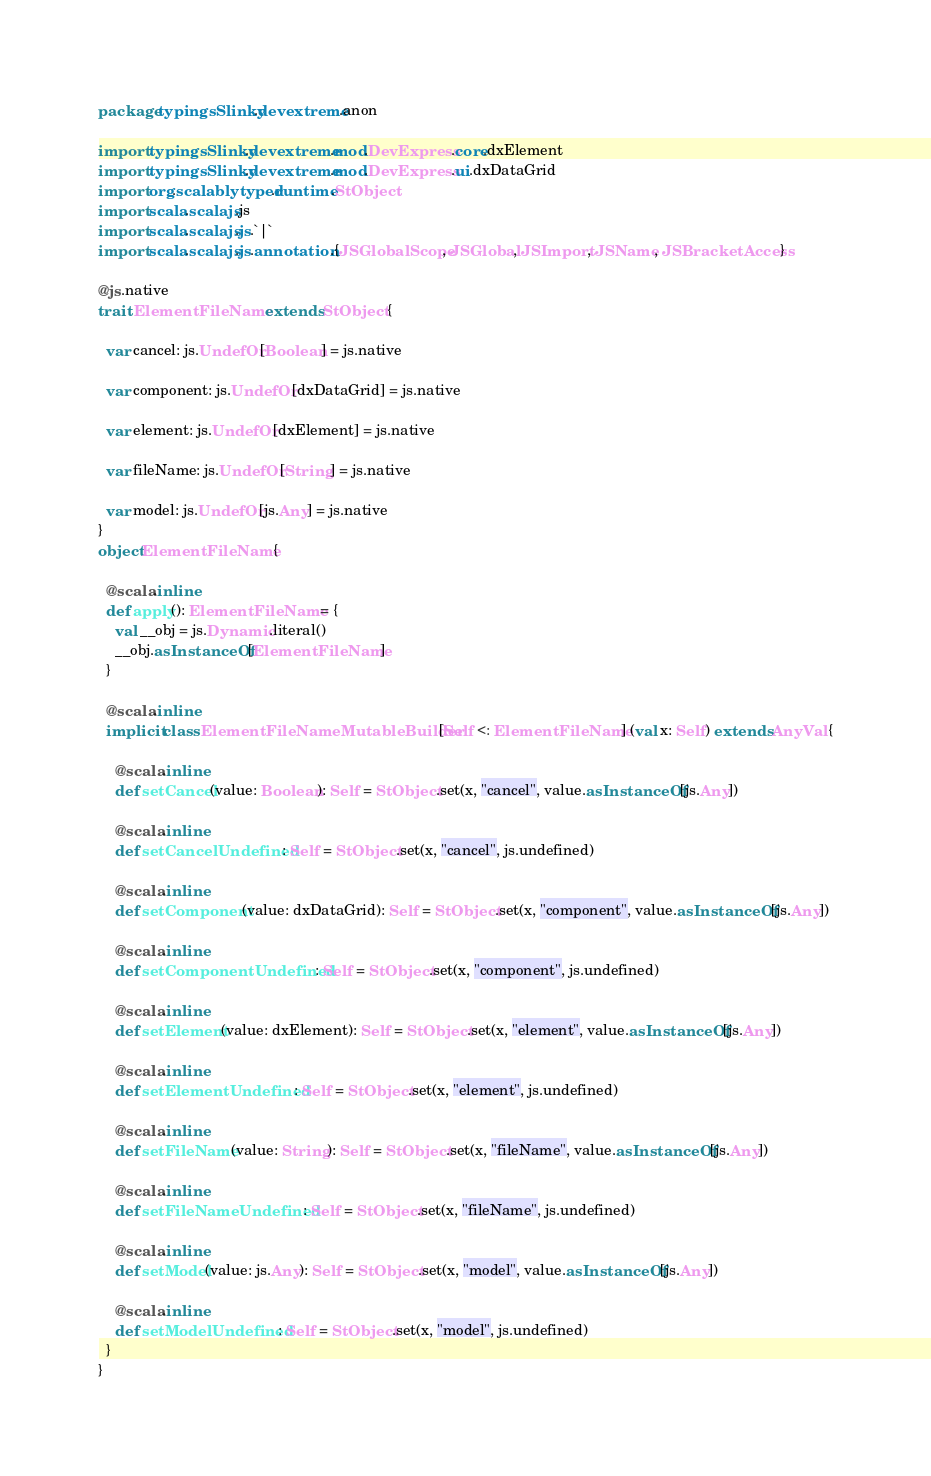Convert code to text. <code><loc_0><loc_0><loc_500><loc_500><_Scala_>package typingsSlinky.devextreme.anon

import typingsSlinky.devextreme.mod.DevExpress.core.dxElement
import typingsSlinky.devextreme.mod.DevExpress.ui.dxDataGrid
import org.scalablytyped.runtime.StObject
import scala.scalajs.js
import scala.scalajs.js.`|`
import scala.scalajs.js.annotation.{JSGlobalScope, JSGlobal, JSImport, JSName, JSBracketAccess}

@js.native
trait ElementFileName extends StObject {
  
  var cancel: js.UndefOr[Boolean] = js.native
  
  var component: js.UndefOr[dxDataGrid] = js.native
  
  var element: js.UndefOr[dxElement] = js.native
  
  var fileName: js.UndefOr[String] = js.native
  
  var model: js.UndefOr[js.Any] = js.native
}
object ElementFileName {
  
  @scala.inline
  def apply(): ElementFileName = {
    val __obj = js.Dynamic.literal()
    __obj.asInstanceOf[ElementFileName]
  }
  
  @scala.inline
  implicit class ElementFileNameMutableBuilder[Self <: ElementFileName] (val x: Self) extends AnyVal {
    
    @scala.inline
    def setCancel(value: Boolean): Self = StObject.set(x, "cancel", value.asInstanceOf[js.Any])
    
    @scala.inline
    def setCancelUndefined: Self = StObject.set(x, "cancel", js.undefined)
    
    @scala.inline
    def setComponent(value: dxDataGrid): Self = StObject.set(x, "component", value.asInstanceOf[js.Any])
    
    @scala.inline
    def setComponentUndefined: Self = StObject.set(x, "component", js.undefined)
    
    @scala.inline
    def setElement(value: dxElement): Self = StObject.set(x, "element", value.asInstanceOf[js.Any])
    
    @scala.inline
    def setElementUndefined: Self = StObject.set(x, "element", js.undefined)
    
    @scala.inline
    def setFileName(value: String): Self = StObject.set(x, "fileName", value.asInstanceOf[js.Any])
    
    @scala.inline
    def setFileNameUndefined: Self = StObject.set(x, "fileName", js.undefined)
    
    @scala.inline
    def setModel(value: js.Any): Self = StObject.set(x, "model", value.asInstanceOf[js.Any])
    
    @scala.inline
    def setModelUndefined: Self = StObject.set(x, "model", js.undefined)
  }
}
</code> 